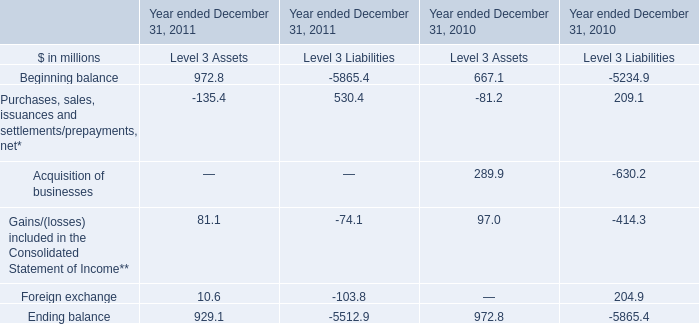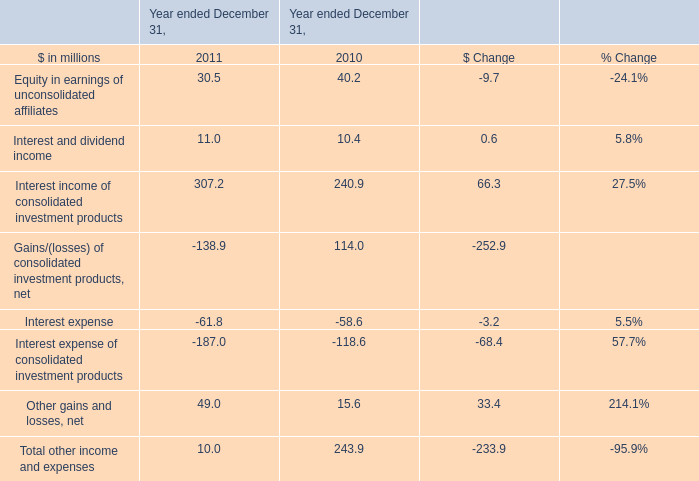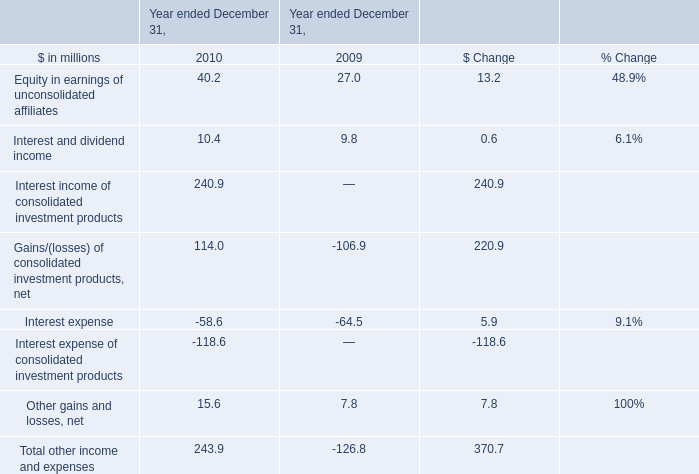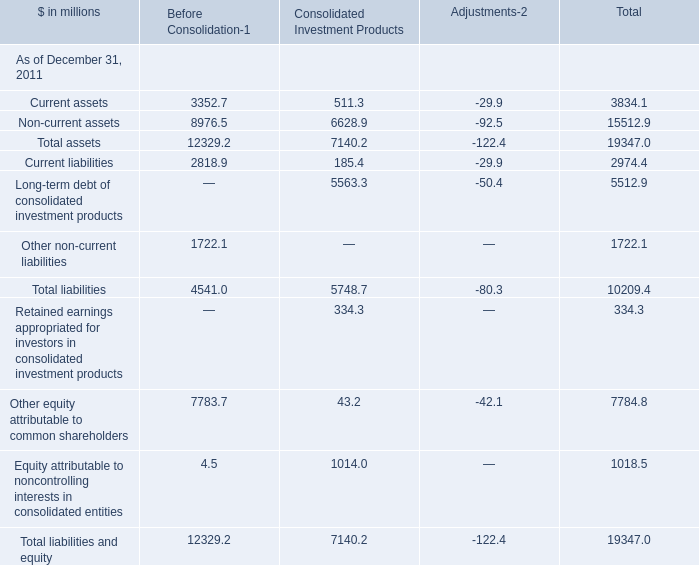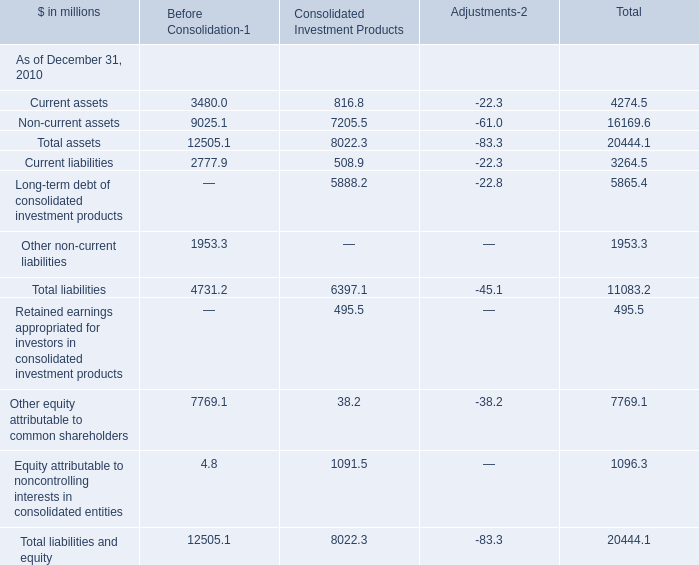What's the total value of all Before Consolidation that are smaller than 2000 in 2010? (in million) 
Computations: (1953.3 + 4.8)
Answer: 1958.1. 